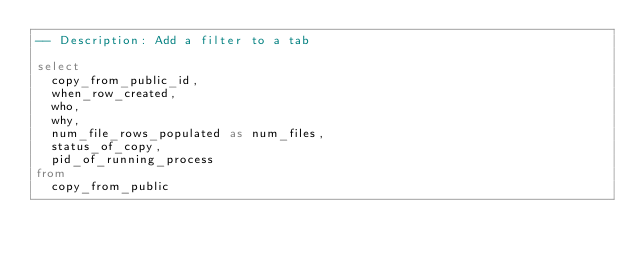Convert code to text. <code><loc_0><loc_0><loc_500><loc_500><_SQL_>-- Description: Add a filter to a tab

select
  copy_from_public_id,
  when_row_created,
  who,
  why, 
  num_file_rows_populated as num_files,
  status_of_copy,
  pid_of_running_process
from
  copy_from_public
</code> 